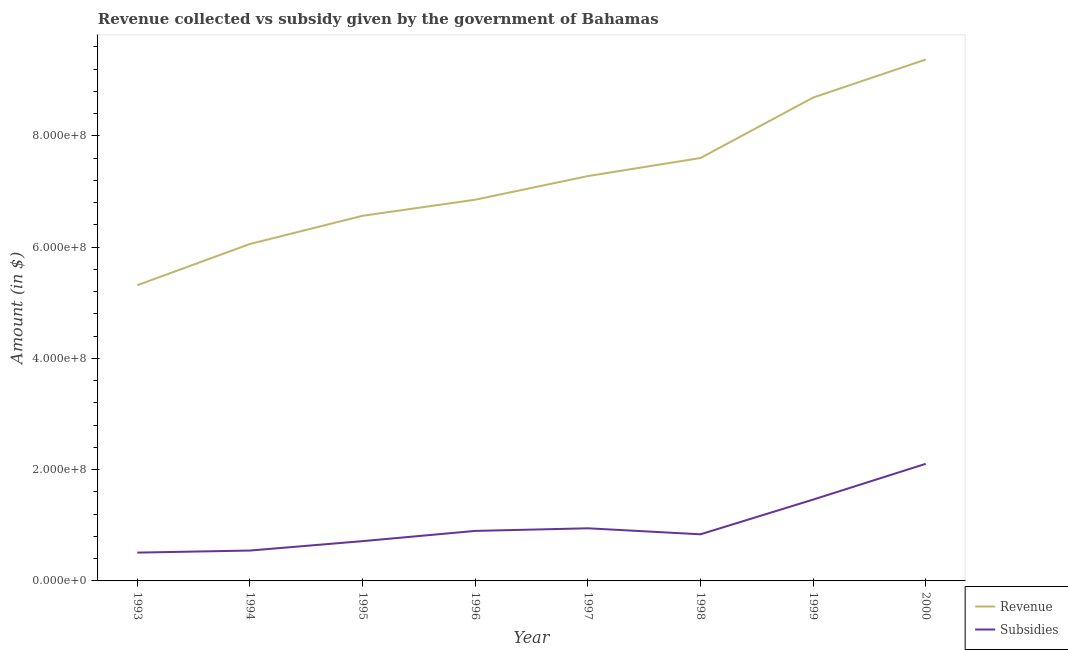How many different coloured lines are there?
Keep it short and to the point. 2. Does the line corresponding to amount of subsidies given intersect with the line corresponding to amount of revenue collected?
Make the answer very short. No. What is the amount of revenue collected in 1997?
Offer a terse response. 7.28e+08. Across all years, what is the maximum amount of subsidies given?
Keep it short and to the point. 2.10e+08. Across all years, what is the minimum amount of subsidies given?
Provide a succinct answer. 5.09e+07. In which year was the amount of subsidies given minimum?
Provide a short and direct response. 1993. What is the total amount of subsidies given in the graph?
Give a very brief answer. 8.02e+08. What is the difference between the amount of subsidies given in 1993 and that in 1996?
Offer a very short reply. -3.90e+07. What is the difference between the amount of subsidies given in 1995 and the amount of revenue collected in 2000?
Your response must be concise. -8.66e+08. What is the average amount of subsidies given per year?
Keep it short and to the point. 1.00e+08. In the year 1998, what is the difference between the amount of subsidies given and amount of revenue collected?
Your answer should be very brief. -6.76e+08. What is the ratio of the amount of subsidies given in 1996 to that in 1998?
Keep it short and to the point. 1.07. What is the difference between the highest and the second highest amount of revenue collected?
Provide a short and direct response. 6.84e+07. What is the difference between the highest and the lowest amount of revenue collected?
Make the answer very short. 4.06e+08. Is the sum of the amount of subsidies given in 1995 and 1999 greater than the maximum amount of revenue collected across all years?
Provide a succinct answer. No. Is the amount of revenue collected strictly greater than the amount of subsidies given over the years?
Your answer should be very brief. Yes. Is the amount of subsidies given strictly less than the amount of revenue collected over the years?
Ensure brevity in your answer.  Yes. How many years are there in the graph?
Your response must be concise. 8. Does the graph contain any zero values?
Your answer should be very brief. No. Does the graph contain grids?
Offer a very short reply. No. How many legend labels are there?
Offer a very short reply. 2. What is the title of the graph?
Offer a terse response. Revenue collected vs subsidy given by the government of Bahamas. Does "Nonresident" appear as one of the legend labels in the graph?
Your response must be concise. No. What is the label or title of the Y-axis?
Make the answer very short. Amount (in $). What is the Amount (in $) in Revenue in 1993?
Ensure brevity in your answer.  5.32e+08. What is the Amount (in $) in Subsidies in 1993?
Ensure brevity in your answer.  5.09e+07. What is the Amount (in $) in Revenue in 1994?
Keep it short and to the point. 6.06e+08. What is the Amount (in $) in Subsidies in 1994?
Ensure brevity in your answer.  5.46e+07. What is the Amount (in $) in Revenue in 1995?
Provide a short and direct response. 6.56e+08. What is the Amount (in $) in Subsidies in 1995?
Your answer should be very brief. 7.15e+07. What is the Amount (in $) in Revenue in 1996?
Make the answer very short. 6.85e+08. What is the Amount (in $) of Subsidies in 1996?
Keep it short and to the point. 8.99e+07. What is the Amount (in $) of Revenue in 1997?
Offer a very short reply. 7.28e+08. What is the Amount (in $) of Subsidies in 1997?
Give a very brief answer. 9.46e+07. What is the Amount (in $) in Revenue in 1998?
Your answer should be very brief. 7.60e+08. What is the Amount (in $) in Subsidies in 1998?
Offer a very short reply. 8.38e+07. What is the Amount (in $) of Revenue in 1999?
Your answer should be very brief. 8.69e+08. What is the Amount (in $) in Subsidies in 1999?
Ensure brevity in your answer.  1.46e+08. What is the Amount (in $) of Revenue in 2000?
Keep it short and to the point. 9.37e+08. What is the Amount (in $) of Subsidies in 2000?
Make the answer very short. 2.10e+08. Across all years, what is the maximum Amount (in $) in Revenue?
Provide a succinct answer. 9.37e+08. Across all years, what is the maximum Amount (in $) of Subsidies?
Ensure brevity in your answer.  2.10e+08. Across all years, what is the minimum Amount (in $) in Revenue?
Provide a succinct answer. 5.32e+08. Across all years, what is the minimum Amount (in $) in Subsidies?
Your response must be concise. 5.09e+07. What is the total Amount (in $) of Revenue in the graph?
Offer a very short reply. 5.77e+09. What is the total Amount (in $) in Subsidies in the graph?
Your response must be concise. 8.02e+08. What is the difference between the Amount (in $) in Revenue in 1993 and that in 1994?
Provide a short and direct response. -7.41e+07. What is the difference between the Amount (in $) in Subsidies in 1993 and that in 1994?
Give a very brief answer. -3.70e+06. What is the difference between the Amount (in $) in Revenue in 1993 and that in 1995?
Offer a very short reply. -1.25e+08. What is the difference between the Amount (in $) of Subsidies in 1993 and that in 1995?
Keep it short and to the point. -2.06e+07. What is the difference between the Amount (in $) in Revenue in 1993 and that in 1996?
Your response must be concise. -1.54e+08. What is the difference between the Amount (in $) in Subsidies in 1993 and that in 1996?
Your answer should be compact. -3.90e+07. What is the difference between the Amount (in $) of Revenue in 1993 and that in 1997?
Provide a succinct answer. -1.96e+08. What is the difference between the Amount (in $) in Subsidies in 1993 and that in 1997?
Your answer should be compact. -4.37e+07. What is the difference between the Amount (in $) in Revenue in 1993 and that in 1998?
Offer a very short reply. -2.29e+08. What is the difference between the Amount (in $) in Subsidies in 1993 and that in 1998?
Offer a very short reply. -3.29e+07. What is the difference between the Amount (in $) in Revenue in 1993 and that in 1999?
Keep it short and to the point. -3.37e+08. What is the difference between the Amount (in $) in Subsidies in 1993 and that in 1999?
Make the answer very short. -9.53e+07. What is the difference between the Amount (in $) of Revenue in 1993 and that in 2000?
Give a very brief answer. -4.06e+08. What is the difference between the Amount (in $) of Subsidies in 1993 and that in 2000?
Provide a short and direct response. -1.60e+08. What is the difference between the Amount (in $) of Revenue in 1994 and that in 1995?
Keep it short and to the point. -5.07e+07. What is the difference between the Amount (in $) of Subsidies in 1994 and that in 1995?
Provide a succinct answer. -1.69e+07. What is the difference between the Amount (in $) in Revenue in 1994 and that in 1996?
Offer a very short reply. -7.96e+07. What is the difference between the Amount (in $) of Subsidies in 1994 and that in 1996?
Ensure brevity in your answer.  -3.53e+07. What is the difference between the Amount (in $) in Revenue in 1994 and that in 1997?
Your answer should be very brief. -1.22e+08. What is the difference between the Amount (in $) in Subsidies in 1994 and that in 1997?
Offer a very short reply. -4.00e+07. What is the difference between the Amount (in $) of Revenue in 1994 and that in 1998?
Your answer should be very brief. -1.55e+08. What is the difference between the Amount (in $) in Subsidies in 1994 and that in 1998?
Your answer should be very brief. -2.92e+07. What is the difference between the Amount (in $) of Revenue in 1994 and that in 1999?
Offer a very short reply. -2.63e+08. What is the difference between the Amount (in $) in Subsidies in 1994 and that in 1999?
Keep it short and to the point. -9.16e+07. What is the difference between the Amount (in $) of Revenue in 1994 and that in 2000?
Provide a short and direct response. -3.32e+08. What is the difference between the Amount (in $) in Subsidies in 1994 and that in 2000?
Ensure brevity in your answer.  -1.56e+08. What is the difference between the Amount (in $) of Revenue in 1995 and that in 1996?
Provide a short and direct response. -2.89e+07. What is the difference between the Amount (in $) of Subsidies in 1995 and that in 1996?
Your answer should be compact. -1.84e+07. What is the difference between the Amount (in $) in Revenue in 1995 and that in 1997?
Keep it short and to the point. -7.14e+07. What is the difference between the Amount (in $) of Subsidies in 1995 and that in 1997?
Make the answer very short. -2.31e+07. What is the difference between the Amount (in $) in Revenue in 1995 and that in 1998?
Provide a short and direct response. -1.04e+08. What is the difference between the Amount (in $) of Subsidies in 1995 and that in 1998?
Offer a terse response. -1.23e+07. What is the difference between the Amount (in $) of Revenue in 1995 and that in 1999?
Provide a succinct answer. -2.12e+08. What is the difference between the Amount (in $) in Subsidies in 1995 and that in 1999?
Offer a terse response. -7.47e+07. What is the difference between the Amount (in $) in Revenue in 1995 and that in 2000?
Provide a short and direct response. -2.81e+08. What is the difference between the Amount (in $) in Subsidies in 1995 and that in 2000?
Your response must be concise. -1.39e+08. What is the difference between the Amount (in $) in Revenue in 1996 and that in 1997?
Give a very brief answer. -4.25e+07. What is the difference between the Amount (in $) of Subsidies in 1996 and that in 1997?
Make the answer very short. -4.70e+06. What is the difference between the Amount (in $) in Revenue in 1996 and that in 1998?
Provide a short and direct response. -7.49e+07. What is the difference between the Amount (in $) of Subsidies in 1996 and that in 1998?
Keep it short and to the point. 6.11e+06. What is the difference between the Amount (in $) of Revenue in 1996 and that in 1999?
Keep it short and to the point. -1.84e+08. What is the difference between the Amount (in $) of Subsidies in 1996 and that in 1999?
Your response must be concise. -5.63e+07. What is the difference between the Amount (in $) of Revenue in 1996 and that in 2000?
Your answer should be compact. -2.52e+08. What is the difference between the Amount (in $) in Subsidies in 1996 and that in 2000?
Give a very brief answer. -1.21e+08. What is the difference between the Amount (in $) of Revenue in 1997 and that in 1998?
Give a very brief answer. -3.25e+07. What is the difference between the Amount (in $) of Subsidies in 1997 and that in 1998?
Give a very brief answer. 1.08e+07. What is the difference between the Amount (in $) of Revenue in 1997 and that in 1999?
Offer a terse response. -1.41e+08. What is the difference between the Amount (in $) in Subsidies in 1997 and that in 1999?
Ensure brevity in your answer.  -5.16e+07. What is the difference between the Amount (in $) in Revenue in 1997 and that in 2000?
Provide a succinct answer. -2.10e+08. What is the difference between the Amount (in $) of Subsidies in 1997 and that in 2000?
Your answer should be compact. -1.16e+08. What is the difference between the Amount (in $) of Revenue in 1998 and that in 1999?
Provide a succinct answer. -1.09e+08. What is the difference between the Amount (in $) in Subsidies in 1998 and that in 1999?
Offer a terse response. -6.24e+07. What is the difference between the Amount (in $) in Revenue in 1998 and that in 2000?
Make the answer very short. -1.77e+08. What is the difference between the Amount (in $) in Subsidies in 1998 and that in 2000?
Offer a terse response. -1.27e+08. What is the difference between the Amount (in $) of Revenue in 1999 and that in 2000?
Offer a very short reply. -6.84e+07. What is the difference between the Amount (in $) of Subsidies in 1999 and that in 2000?
Offer a very short reply. -6.43e+07. What is the difference between the Amount (in $) of Revenue in 1993 and the Amount (in $) of Subsidies in 1994?
Keep it short and to the point. 4.77e+08. What is the difference between the Amount (in $) of Revenue in 1993 and the Amount (in $) of Subsidies in 1995?
Provide a succinct answer. 4.60e+08. What is the difference between the Amount (in $) in Revenue in 1993 and the Amount (in $) in Subsidies in 1996?
Keep it short and to the point. 4.42e+08. What is the difference between the Amount (in $) of Revenue in 1993 and the Amount (in $) of Subsidies in 1997?
Keep it short and to the point. 4.37e+08. What is the difference between the Amount (in $) of Revenue in 1993 and the Amount (in $) of Subsidies in 1998?
Provide a short and direct response. 4.48e+08. What is the difference between the Amount (in $) in Revenue in 1993 and the Amount (in $) in Subsidies in 1999?
Provide a succinct answer. 3.85e+08. What is the difference between the Amount (in $) of Revenue in 1993 and the Amount (in $) of Subsidies in 2000?
Provide a succinct answer. 3.21e+08. What is the difference between the Amount (in $) of Revenue in 1994 and the Amount (in $) of Subsidies in 1995?
Offer a very short reply. 5.34e+08. What is the difference between the Amount (in $) in Revenue in 1994 and the Amount (in $) in Subsidies in 1996?
Your response must be concise. 5.16e+08. What is the difference between the Amount (in $) in Revenue in 1994 and the Amount (in $) in Subsidies in 1997?
Your answer should be very brief. 5.11e+08. What is the difference between the Amount (in $) of Revenue in 1994 and the Amount (in $) of Subsidies in 1998?
Offer a very short reply. 5.22e+08. What is the difference between the Amount (in $) in Revenue in 1994 and the Amount (in $) in Subsidies in 1999?
Keep it short and to the point. 4.59e+08. What is the difference between the Amount (in $) of Revenue in 1994 and the Amount (in $) of Subsidies in 2000?
Keep it short and to the point. 3.95e+08. What is the difference between the Amount (in $) in Revenue in 1995 and the Amount (in $) in Subsidies in 1996?
Provide a short and direct response. 5.66e+08. What is the difference between the Amount (in $) of Revenue in 1995 and the Amount (in $) of Subsidies in 1997?
Provide a short and direct response. 5.62e+08. What is the difference between the Amount (in $) of Revenue in 1995 and the Amount (in $) of Subsidies in 1998?
Provide a short and direct response. 5.73e+08. What is the difference between the Amount (in $) in Revenue in 1995 and the Amount (in $) in Subsidies in 1999?
Ensure brevity in your answer.  5.10e+08. What is the difference between the Amount (in $) in Revenue in 1995 and the Amount (in $) in Subsidies in 2000?
Offer a terse response. 4.46e+08. What is the difference between the Amount (in $) in Revenue in 1996 and the Amount (in $) in Subsidies in 1997?
Ensure brevity in your answer.  5.91e+08. What is the difference between the Amount (in $) in Revenue in 1996 and the Amount (in $) in Subsidies in 1998?
Provide a short and direct response. 6.01e+08. What is the difference between the Amount (in $) of Revenue in 1996 and the Amount (in $) of Subsidies in 1999?
Make the answer very short. 5.39e+08. What is the difference between the Amount (in $) in Revenue in 1996 and the Amount (in $) in Subsidies in 2000?
Ensure brevity in your answer.  4.75e+08. What is the difference between the Amount (in $) in Revenue in 1997 and the Amount (in $) in Subsidies in 1998?
Your answer should be compact. 6.44e+08. What is the difference between the Amount (in $) of Revenue in 1997 and the Amount (in $) of Subsidies in 1999?
Provide a succinct answer. 5.81e+08. What is the difference between the Amount (in $) in Revenue in 1997 and the Amount (in $) in Subsidies in 2000?
Your answer should be very brief. 5.17e+08. What is the difference between the Amount (in $) of Revenue in 1998 and the Amount (in $) of Subsidies in 1999?
Your response must be concise. 6.14e+08. What is the difference between the Amount (in $) in Revenue in 1998 and the Amount (in $) in Subsidies in 2000?
Make the answer very short. 5.50e+08. What is the difference between the Amount (in $) in Revenue in 1999 and the Amount (in $) in Subsidies in 2000?
Keep it short and to the point. 6.58e+08. What is the average Amount (in $) in Revenue per year?
Ensure brevity in your answer.  7.22e+08. What is the average Amount (in $) in Subsidies per year?
Ensure brevity in your answer.  1.00e+08. In the year 1993, what is the difference between the Amount (in $) of Revenue and Amount (in $) of Subsidies?
Give a very brief answer. 4.81e+08. In the year 1994, what is the difference between the Amount (in $) in Revenue and Amount (in $) in Subsidies?
Give a very brief answer. 5.51e+08. In the year 1995, what is the difference between the Amount (in $) in Revenue and Amount (in $) in Subsidies?
Keep it short and to the point. 5.85e+08. In the year 1996, what is the difference between the Amount (in $) of Revenue and Amount (in $) of Subsidies?
Offer a very short reply. 5.95e+08. In the year 1997, what is the difference between the Amount (in $) in Revenue and Amount (in $) in Subsidies?
Ensure brevity in your answer.  6.33e+08. In the year 1998, what is the difference between the Amount (in $) of Revenue and Amount (in $) of Subsidies?
Your answer should be compact. 6.76e+08. In the year 1999, what is the difference between the Amount (in $) in Revenue and Amount (in $) in Subsidies?
Your response must be concise. 7.23e+08. In the year 2000, what is the difference between the Amount (in $) of Revenue and Amount (in $) of Subsidies?
Your answer should be compact. 7.27e+08. What is the ratio of the Amount (in $) of Revenue in 1993 to that in 1994?
Your response must be concise. 0.88. What is the ratio of the Amount (in $) of Subsidies in 1993 to that in 1994?
Keep it short and to the point. 0.93. What is the ratio of the Amount (in $) in Revenue in 1993 to that in 1995?
Ensure brevity in your answer.  0.81. What is the ratio of the Amount (in $) in Subsidies in 1993 to that in 1995?
Keep it short and to the point. 0.71. What is the ratio of the Amount (in $) of Revenue in 1993 to that in 1996?
Provide a short and direct response. 0.78. What is the ratio of the Amount (in $) in Subsidies in 1993 to that in 1996?
Your response must be concise. 0.57. What is the ratio of the Amount (in $) of Revenue in 1993 to that in 1997?
Give a very brief answer. 0.73. What is the ratio of the Amount (in $) in Subsidies in 1993 to that in 1997?
Your answer should be very brief. 0.54. What is the ratio of the Amount (in $) of Revenue in 1993 to that in 1998?
Provide a succinct answer. 0.7. What is the ratio of the Amount (in $) in Subsidies in 1993 to that in 1998?
Provide a short and direct response. 0.61. What is the ratio of the Amount (in $) of Revenue in 1993 to that in 1999?
Your response must be concise. 0.61. What is the ratio of the Amount (in $) in Subsidies in 1993 to that in 1999?
Give a very brief answer. 0.35. What is the ratio of the Amount (in $) of Revenue in 1993 to that in 2000?
Your answer should be compact. 0.57. What is the ratio of the Amount (in $) of Subsidies in 1993 to that in 2000?
Your response must be concise. 0.24. What is the ratio of the Amount (in $) of Revenue in 1994 to that in 1995?
Offer a terse response. 0.92. What is the ratio of the Amount (in $) in Subsidies in 1994 to that in 1995?
Give a very brief answer. 0.76. What is the ratio of the Amount (in $) of Revenue in 1994 to that in 1996?
Your answer should be very brief. 0.88. What is the ratio of the Amount (in $) of Subsidies in 1994 to that in 1996?
Provide a short and direct response. 0.61. What is the ratio of the Amount (in $) in Revenue in 1994 to that in 1997?
Provide a succinct answer. 0.83. What is the ratio of the Amount (in $) in Subsidies in 1994 to that in 1997?
Your answer should be very brief. 0.58. What is the ratio of the Amount (in $) of Revenue in 1994 to that in 1998?
Make the answer very short. 0.8. What is the ratio of the Amount (in $) in Subsidies in 1994 to that in 1998?
Provide a succinct answer. 0.65. What is the ratio of the Amount (in $) of Revenue in 1994 to that in 1999?
Give a very brief answer. 0.7. What is the ratio of the Amount (in $) of Subsidies in 1994 to that in 1999?
Your response must be concise. 0.37. What is the ratio of the Amount (in $) of Revenue in 1994 to that in 2000?
Give a very brief answer. 0.65. What is the ratio of the Amount (in $) in Subsidies in 1994 to that in 2000?
Your answer should be compact. 0.26. What is the ratio of the Amount (in $) in Revenue in 1995 to that in 1996?
Provide a short and direct response. 0.96. What is the ratio of the Amount (in $) of Subsidies in 1995 to that in 1996?
Provide a succinct answer. 0.8. What is the ratio of the Amount (in $) of Revenue in 1995 to that in 1997?
Ensure brevity in your answer.  0.9. What is the ratio of the Amount (in $) of Subsidies in 1995 to that in 1997?
Your response must be concise. 0.76. What is the ratio of the Amount (in $) in Revenue in 1995 to that in 1998?
Give a very brief answer. 0.86. What is the ratio of the Amount (in $) of Subsidies in 1995 to that in 1998?
Your answer should be compact. 0.85. What is the ratio of the Amount (in $) in Revenue in 1995 to that in 1999?
Your response must be concise. 0.76. What is the ratio of the Amount (in $) in Subsidies in 1995 to that in 1999?
Offer a very short reply. 0.49. What is the ratio of the Amount (in $) in Revenue in 1995 to that in 2000?
Keep it short and to the point. 0.7. What is the ratio of the Amount (in $) of Subsidies in 1995 to that in 2000?
Make the answer very short. 0.34. What is the ratio of the Amount (in $) of Revenue in 1996 to that in 1997?
Keep it short and to the point. 0.94. What is the ratio of the Amount (in $) in Subsidies in 1996 to that in 1997?
Give a very brief answer. 0.95. What is the ratio of the Amount (in $) in Revenue in 1996 to that in 1998?
Ensure brevity in your answer.  0.9. What is the ratio of the Amount (in $) of Subsidies in 1996 to that in 1998?
Give a very brief answer. 1.07. What is the ratio of the Amount (in $) in Revenue in 1996 to that in 1999?
Ensure brevity in your answer.  0.79. What is the ratio of the Amount (in $) in Subsidies in 1996 to that in 1999?
Your answer should be compact. 0.62. What is the ratio of the Amount (in $) in Revenue in 1996 to that in 2000?
Give a very brief answer. 0.73. What is the ratio of the Amount (in $) in Subsidies in 1996 to that in 2000?
Ensure brevity in your answer.  0.43. What is the ratio of the Amount (in $) of Revenue in 1997 to that in 1998?
Provide a short and direct response. 0.96. What is the ratio of the Amount (in $) in Subsidies in 1997 to that in 1998?
Offer a terse response. 1.13. What is the ratio of the Amount (in $) in Revenue in 1997 to that in 1999?
Give a very brief answer. 0.84. What is the ratio of the Amount (in $) of Subsidies in 1997 to that in 1999?
Ensure brevity in your answer.  0.65. What is the ratio of the Amount (in $) of Revenue in 1997 to that in 2000?
Make the answer very short. 0.78. What is the ratio of the Amount (in $) of Subsidies in 1997 to that in 2000?
Provide a short and direct response. 0.45. What is the ratio of the Amount (in $) in Revenue in 1998 to that in 1999?
Offer a terse response. 0.88. What is the ratio of the Amount (in $) of Subsidies in 1998 to that in 1999?
Make the answer very short. 0.57. What is the ratio of the Amount (in $) of Revenue in 1998 to that in 2000?
Offer a very short reply. 0.81. What is the ratio of the Amount (in $) in Subsidies in 1998 to that in 2000?
Provide a succinct answer. 0.4. What is the ratio of the Amount (in $) of Revenue in 1999 to that in 2000?
Ensure brevity in your answer.  0.93. What is the ratio of the Amount (in $) in Subsidies in 1999 to that in 2000?
Ensure brevity in your answer.  0.69. What is the difference between the highest and the second highest Amount (in $) in Revenue?
Provide a succinct answer. 6.84e+07. What is the difference between the highest and the second highest Amount (in $) in Subsidies?
Ensure brevity in your answer.  6.43e+07. What is the difference between the highest and the lowest Amount (in $) in Revenue?
Ensure brevity in your answer.  4.06e+08. What is the difference between the highest and the lowest Amount (in $) of Subsidies?
Ensure brevity in your answer.  1.60e+08. 